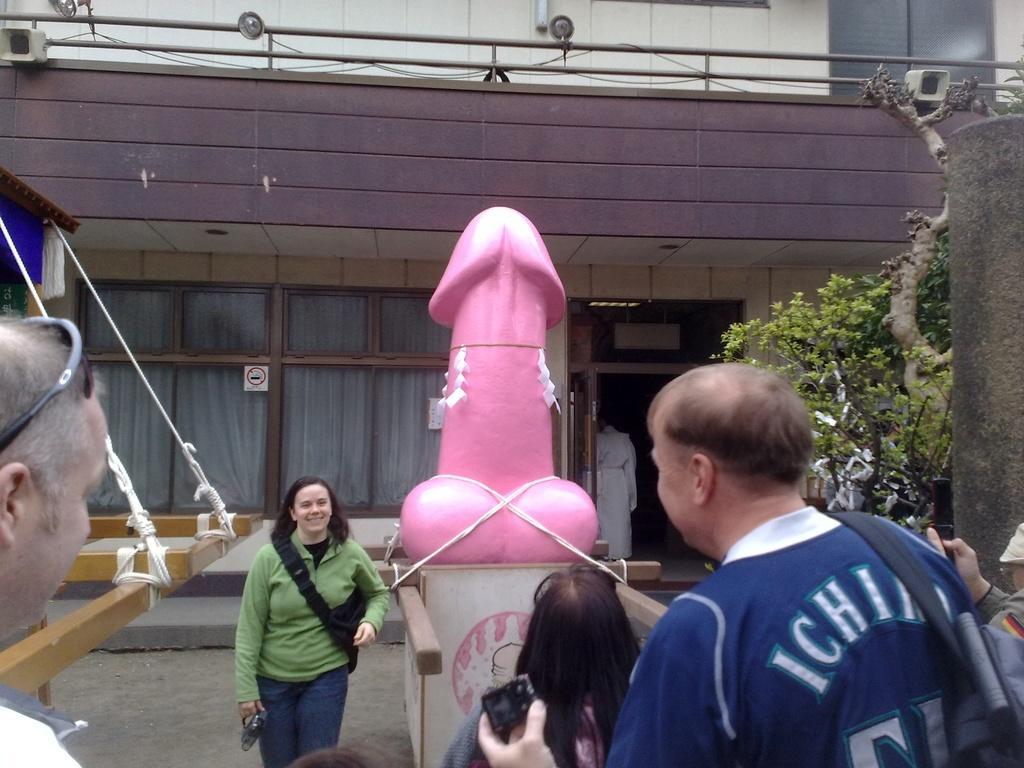Please provide a concise description of this image. In the foreground of the picture there are people. In the center of the picture there are tree, statue, wooden object and rope. In the background there is a building, to the building there are glass windows, door, railing and lights. 